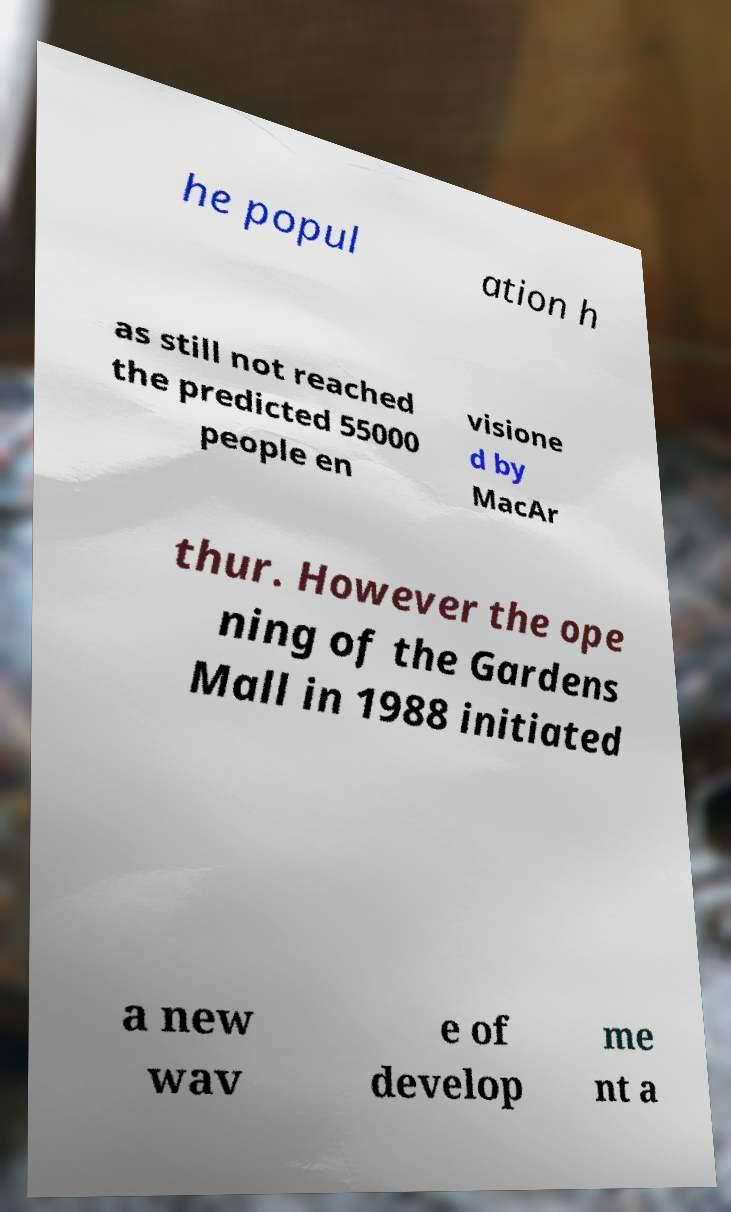Could you assist in decoding the text presented in this image and type it out clearly? he popul ation h as still not reached the predicted 55000 people en visione d by MacAr thur. However the ope ning of the Gardens Mall in 1988 initiated a new wav e of develop me nt a 